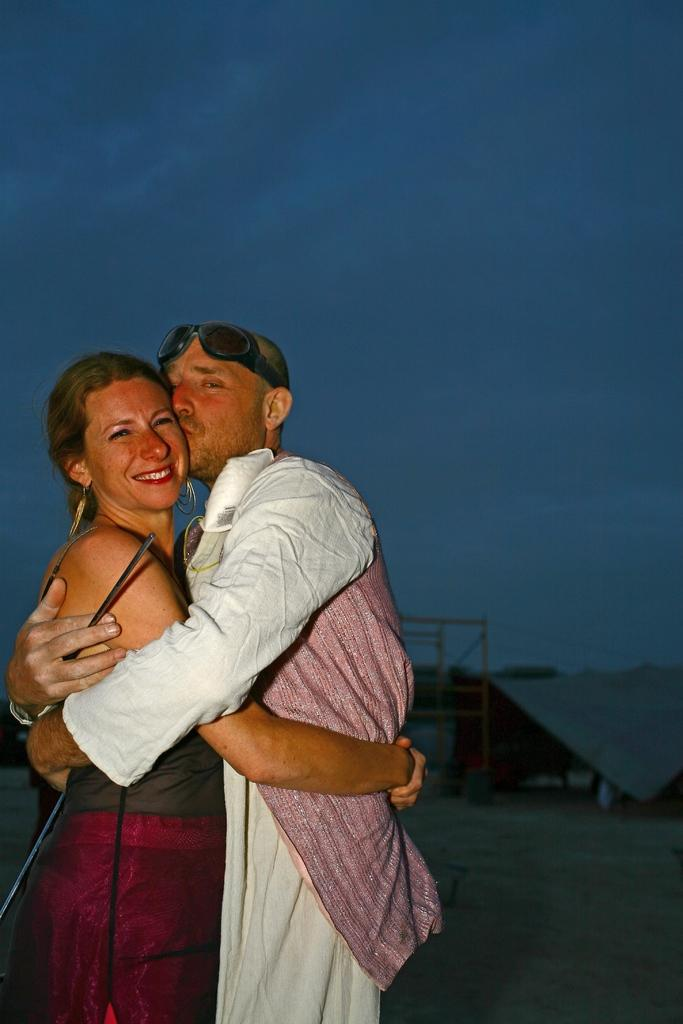How many people are present in the image? There are two people standing on the ground. What can be seen in the background of the image? There are iron rods and a tent in the background. What is visible in the sky in the image? The sky is visible in the background. What type of pig can be seen feeling the grass in the image? There is no pig present in the image, and therefore no such activity can be observed. 